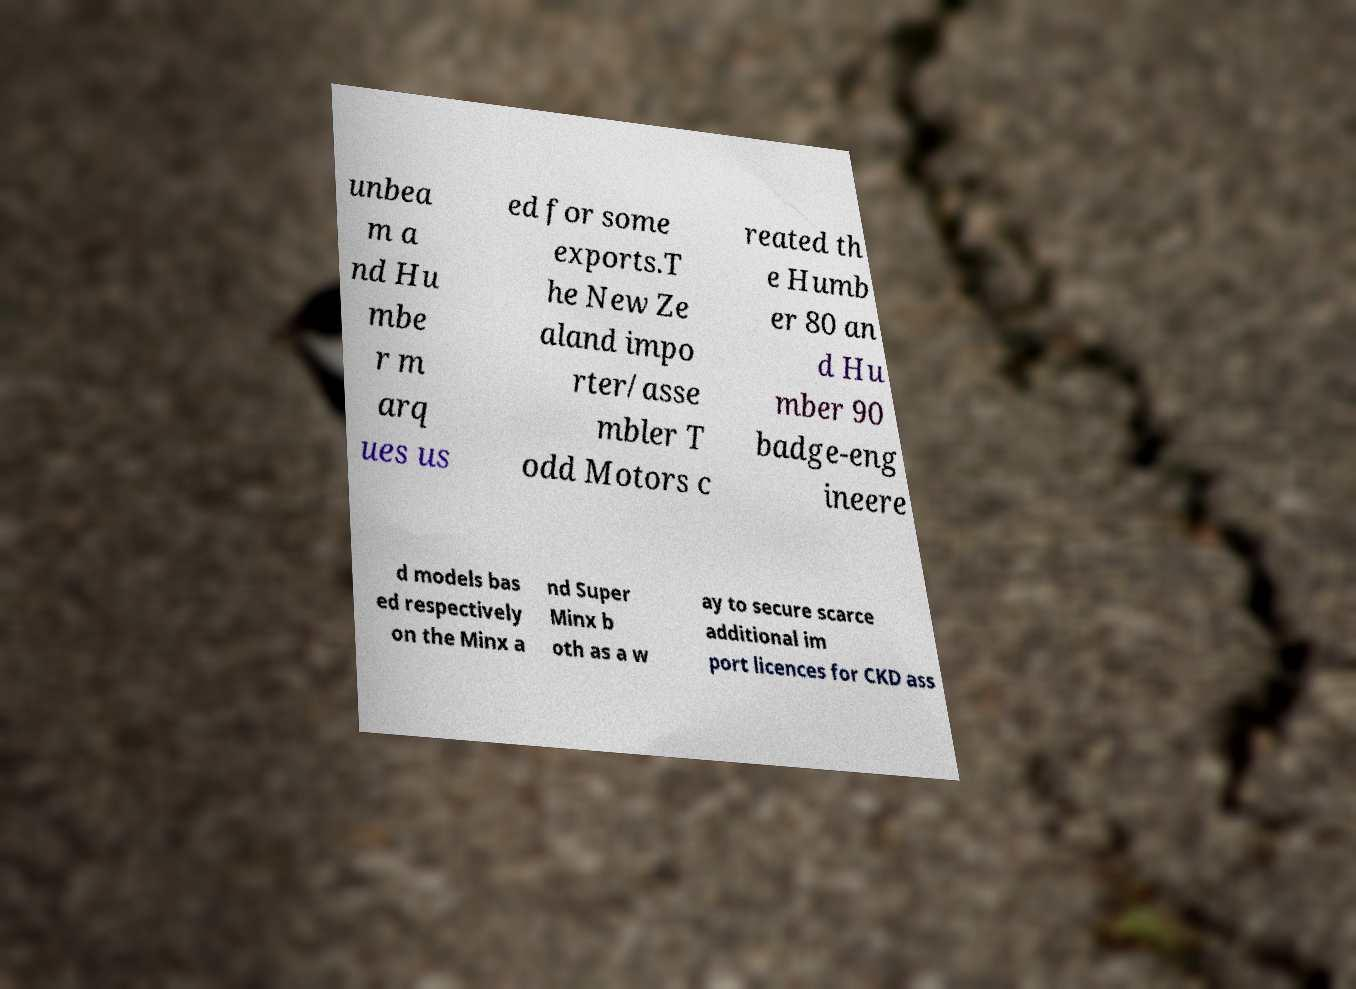I need the written content from this picture converted into text. Can you do that? unbea m a nd Hu mbe r m arq ues us ed for some exports.T he New Ze aland impo rter/asse mbler T odd Motors c reated th e Humb er 80 an d Hu mber 90 badge-eng ineere d models bas ed respectively on the Minx a nd Super Minx b oth as a w ay to secure scarce additional im port licences for CKD ass 